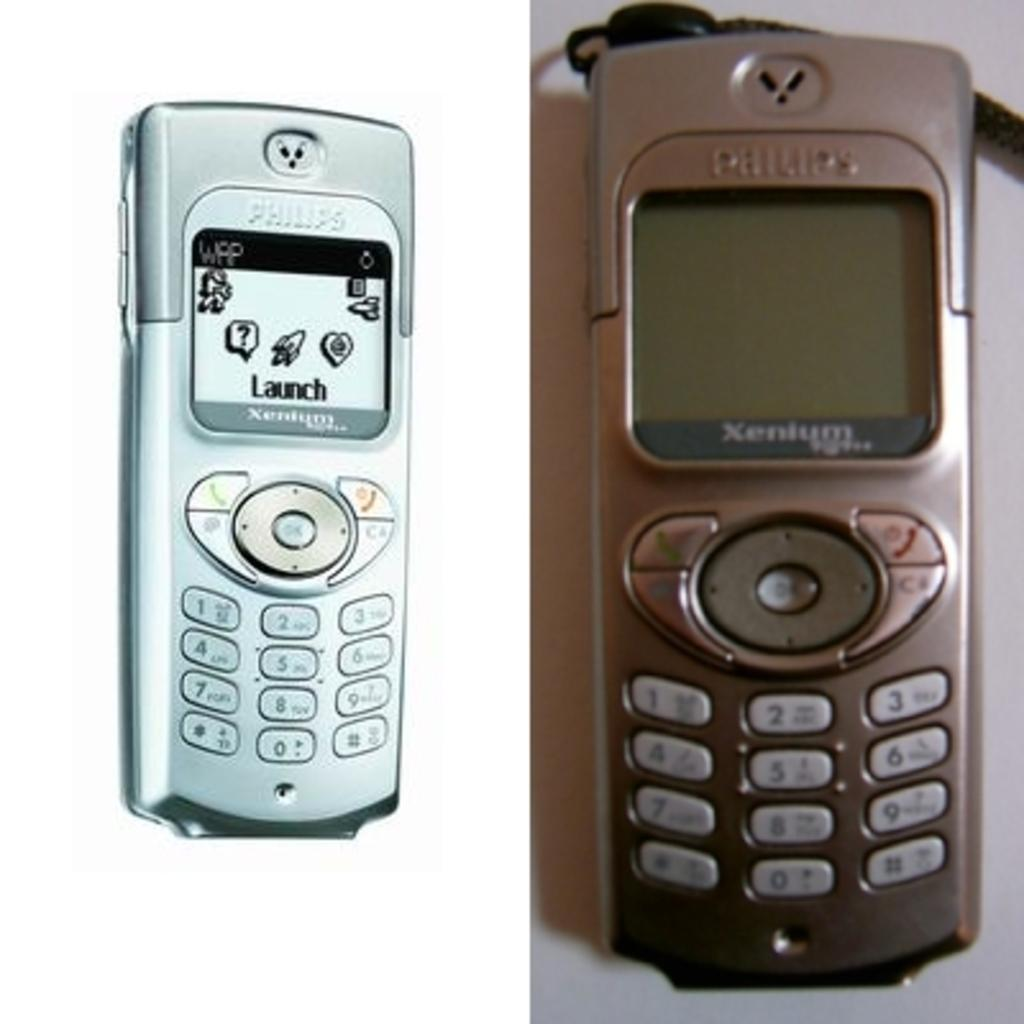<image>
Render a clear and concise summary of the photo. Two Phillips smartphones that say Xenium as the company on the front screen. 